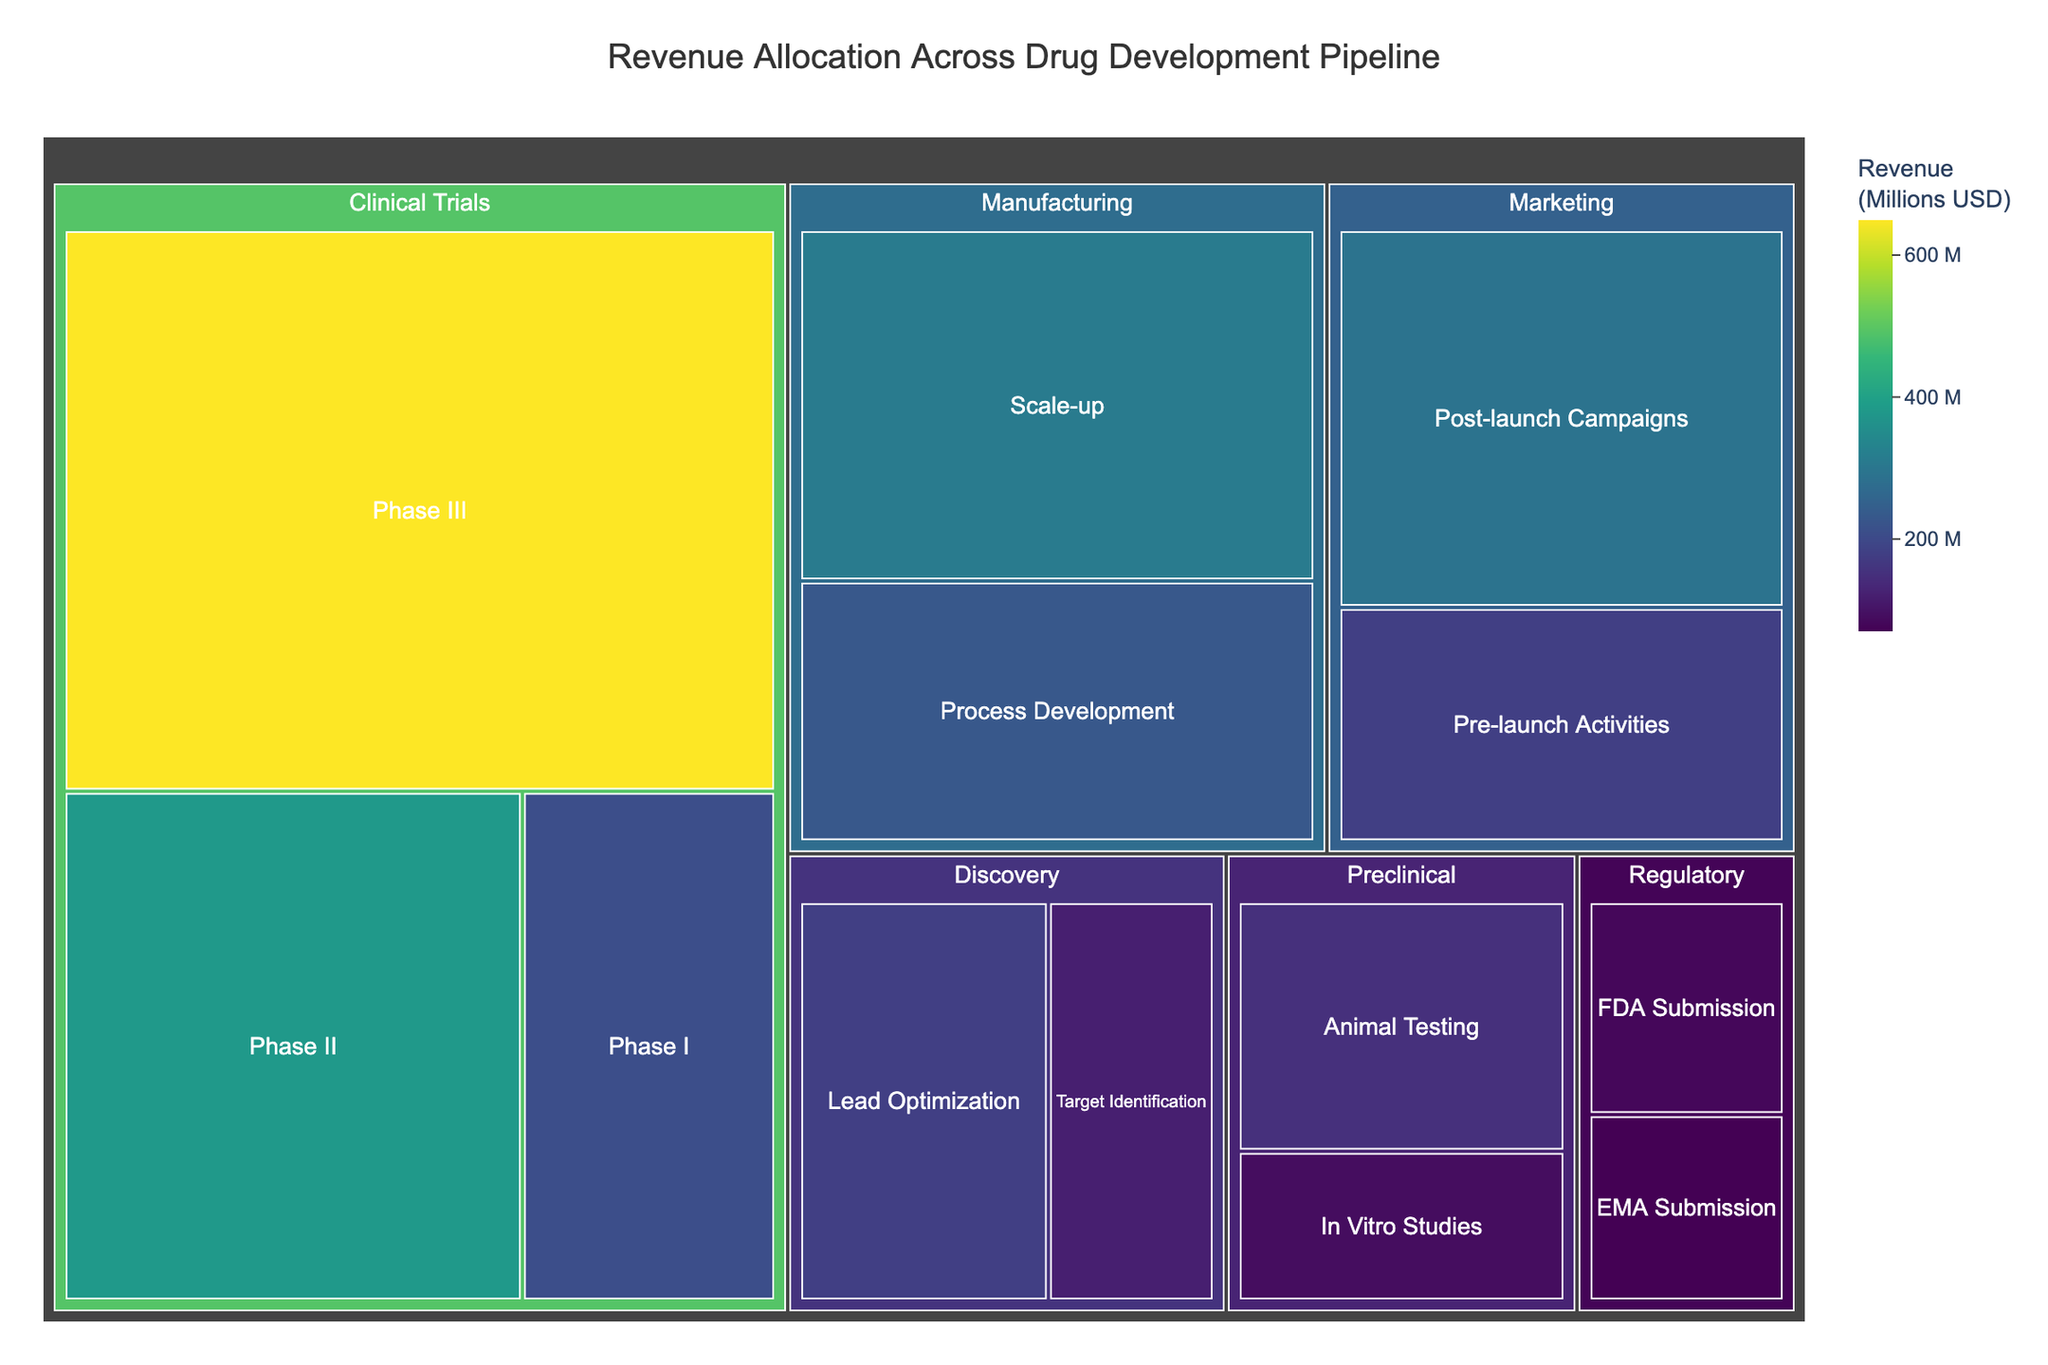what is the title of the figure? The title of the figure is displayed at the top.
Answer: Revenue Allocation Across Drug Development Pipeline Which stage has the highest revenue allocation? The stage with the largest area will have the highest revenue allocation compared to others.
Answer: Clinical Trials What is the total revenue allocated to Preclinical studies? Add the revenue from 'In Vitro Studies' and 'Animal Testing': 90 + 150.
Answer: 240 million USD What is the smallest phase in terms of revenue within the Clinical Trials stage? Look for the smallest block within the Clinical Trials section, which is 'Phase I.'
Answer: Phase I Compare the revenue allocated to FDA Submission and EMA Submission. Which is higher? Check the blocks labeled 'FDA Submission' and 'EMA Submission'. The one with the larger area has higher revenue.
Answer: FDA Submission How much revenue is allocated to Manufacturing? Sum the revenue of 'Process Development' and 'Scale-up': 230 + 310.
Answer: 540 million USD What percentage of total revenue is allocated to the Marketing stage? Sum the revenue for 'Pre-launch Activities' and 'Post-launch Campaigns', then divide by total revenue and multiply by 100: (180 + 290) / 2940 * 100.
Answer: 16% Which stage has more revenue: Discovery or Regulatory? Compare the summed revenues: Discovery (120 + 180) versus Regulatory (80 + 70).
Answer: Discovery What is the average revenue allocated per phase in the Marketing stage? Divide the total marketing revenue by the number of phases: (180 + 290) / 2.
Answer: 235 million USD Is the revenue allocated to Phase III of Clinical Trials greater than the total Preclinical revenue? Compare 'Phase III' revenue (650) with the sum of Preclinical phases: 650 > (90 + 150).
Answer: Yes 